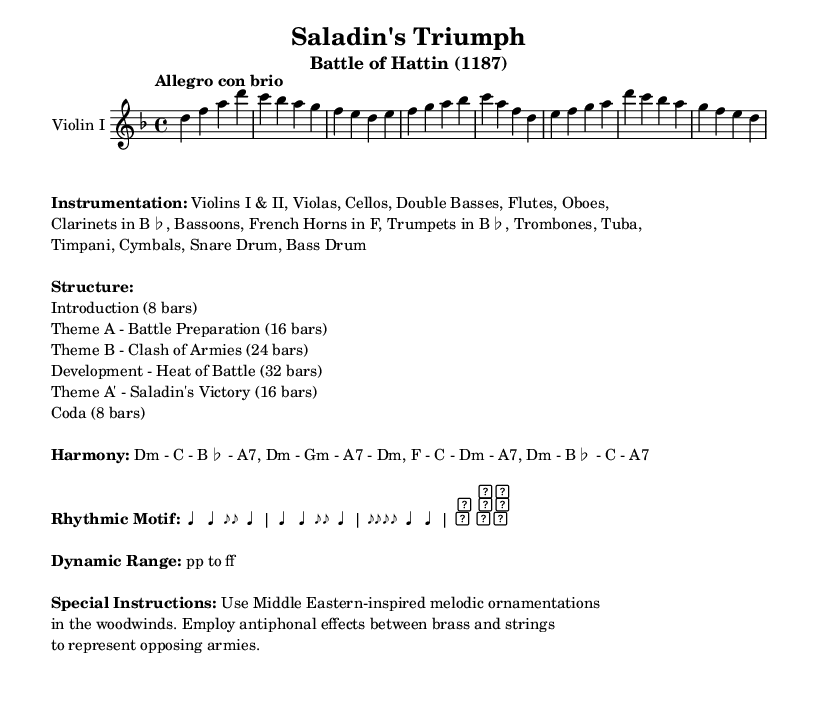What is the key signature of this music? The key signature indicated in the music is one flat, which corresponds to D minor.
Answer: D minor What is the time signature of this music? The time signature shown at the beginning of the piece is 4/4, meaning there are four beats in each measure.
Answer: 4/4 What is the tempo marking for this piece? The tempo marking provided in the music is "Allegro con brio," which suggests a lively and spirited pace.
Answer: Allegro con brio How many bars are in the "Theme A" section? The section labeled "Theme A - Battle Preparation" is indicated to have 16 bars, as stated in the structure listing.
Answer: 16 bars What is the dynamic range indicated in this piece? The dynamic range specified in the music goes from pianissimo to fortissimo, indicating very soft to very loud playing.
Answer: pp to ff What type of melodic ornamentation is suggested in the special instructions? The special instructions recommend using Middle Eastern-inspired melodic ornamentations in the woodwinds, reflecting the historical context of the piece.
Answer: Middle Eastern-inspired How many sections are listed in the structure of this music? Referring to the structured breakdown, there are five main sections listed, each denoting distinct parts of the composition.
Answer: Five sections 